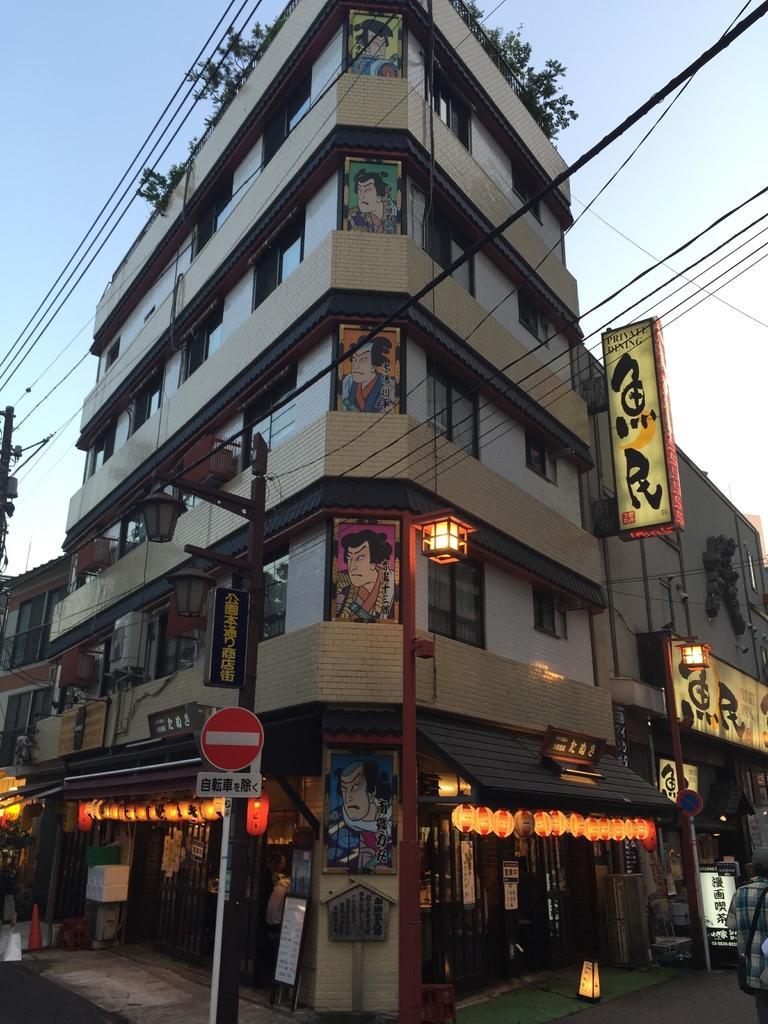Could you give a brief overview of what you see in this image? In this picture we can see there are two poles with boards attached to it. Behind the poles there are buildings, name boards, cables and plants. On the right side of the image, there is a person. On the left side of the image, there is a traffic cone. Behind the buildings there is the sky. 